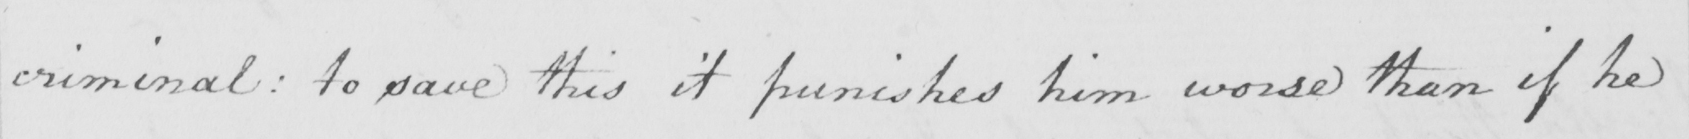What does this handwritten line say? criminal :  to save this it punishes him worse than if he 